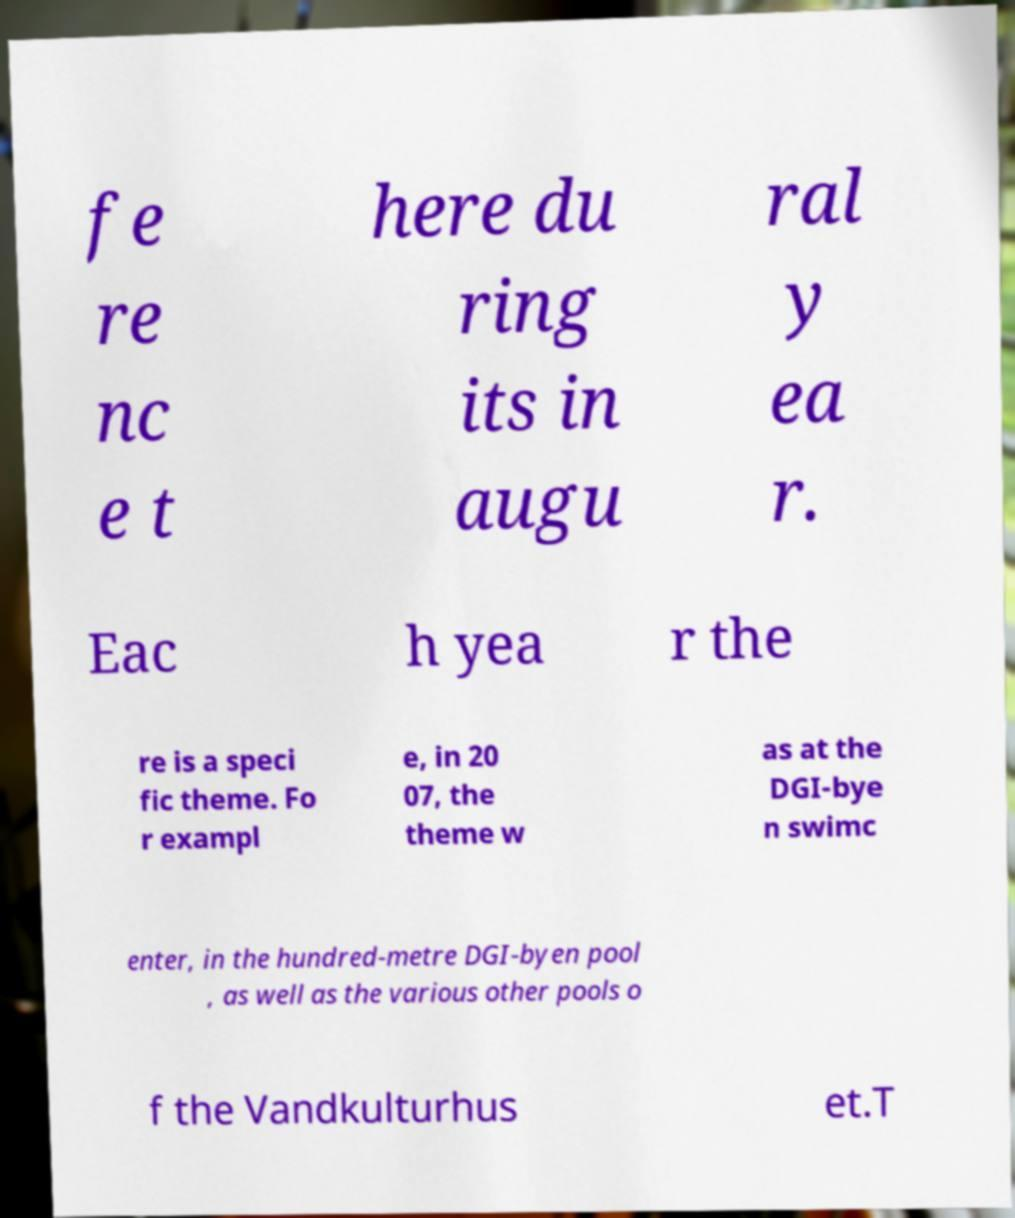Could you assist in decoding the text presented in this image and type it out clearly? fe re nc e t here du ring its in augu ral y ea r. Eac h yea r the re is a speci fic theme. Fo r exampl e, in 20 07, the theme w as at the DGI-bye n swimc enter, in the hundred-metre DGI-byen pool , as well as the various other pools o f the Vandkulturhus et.T 